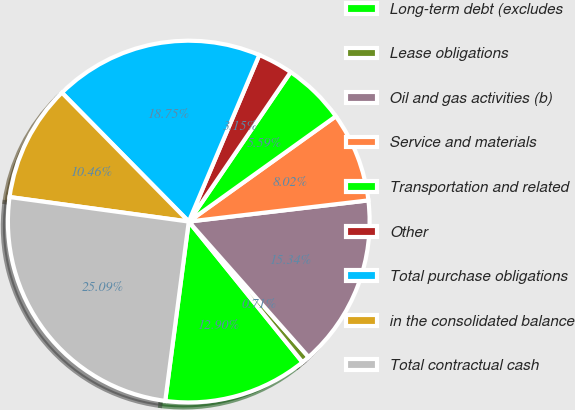Convert chart. <chart><loc_0><loc_0><loc_500><loc_500><pie_chart><fcel>Long-term debt (excludes<fcel>Lease obligations<fcel>Oil and gas activities (b)<fcel>Service and materials<fcel>Transportation and related<fcel>Other<fcel>Total purchase obligations<fcel>in the consolidated balance<fcel>Total contractual cash<nl><fcel>12.9%<fcel>0.71%<fcel>15.34%<fcel>8.02%<fcel>5.59%<fcel>3.15%<fcel>18.75%<fcel>10.46%<fcel>25.09%<nl></chart> 